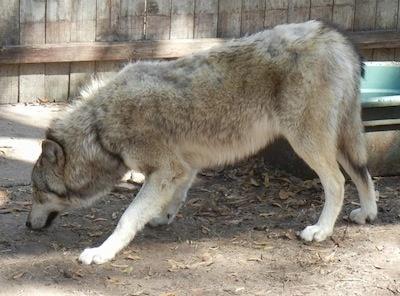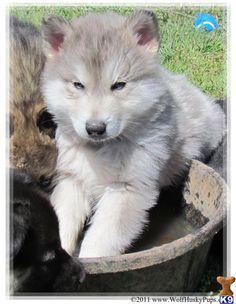The first image is the image on the left, the second image is the image on the right. Given the left and right images, does the statement "Two animals have their tongues out." hold true? Answer yes or no. No. 